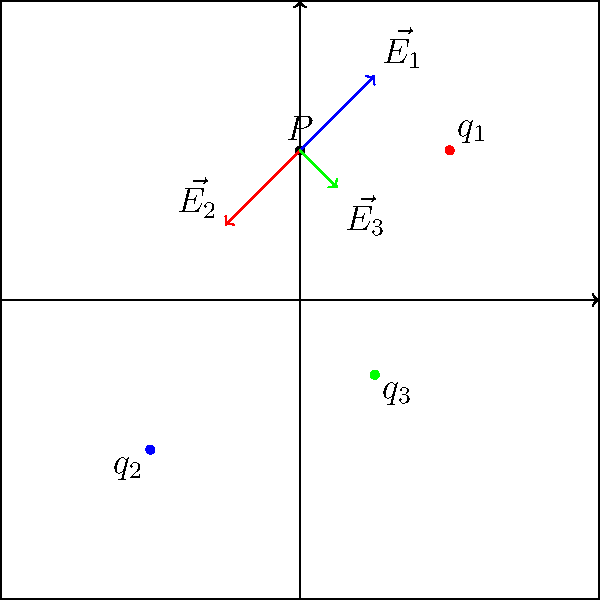In a disordered system, three charged particles are located at positions $\vec{r_1} = (1,1)$, $\vec{r_2} = (-1,-1)$, and $\vec{r_3} = (0.5,-0.5)$ with charges $q_1 = 2e$, $q_2 = -e$, and $q_3 = e$ respectively, where $e$ is the elementary charge. Calculate the total electric field vector $\vec{E_{total}}$ at point $P(0,1)$. Assume the system is in vacuum with permittivity $\epsilon_0$. Express your answer in terms of $\frac{e}{4\pi\epsilon_0}$ and give the x and y components separately. To solve this problem, we'll follow these steps:

1) First, we need to calculate the electric field vector due to each charge using the formula:

   $$\vec{E_i} = \frac{1}{4\pi\epsilon_0} \frac{q_i}{r_i^2} \hat{r_i}$$

   where $\hat{r_i}$ is the unit vector pointing from the charge to point P.

2) For charge $q_1$:
   $\vec{r_{1P}} = (0,1) - (1,1) = (-1,0)$
   $r_1 = \sqrt{(-1)^2 + 0^2} = 1$
   $\hat{r_1} = (-1,0)$
   $$\vec{E_1} = \frac{1}{4\pi\epsilon_0} \frac{2e}{1^2} (-1,0) = -\frac{e}{2\pi\epsilon_0} (1,0)$$

3) For charge $q_2$:
   $\vec{r_{2P}} = (0,1) - (-1,-1) = (1,2)$
   $r_2 = \sqrt{1^2 + 2^2} = \sqrt{5}$
   $\hat{r_2} = (\frac{1}{\sqrt{5}},\frac{2}{\sqrt{5}})$
   $$\vec{E_2} = \frac{1}{4\pi\epsilon_0} \frac{-e}{5} (\frac{1}{\sqrt{5}},\frac{2}{\sqrt{5}}) = -\frac{e}{20\pi\epsilon_0} (\frac{1}{\sqrt{5}},\frac{2}{\sqrt{5}})$$

4) For charge $q_3$:
   $\vec{r_{3P}} = (0,1) - (0.5,-0.5) = (-0.5,1.5)$
   $r_3 = \sqrt{(-0.5)^2 + (1.5)^2} = \sqrt{2.5}$
   $\hat{r_3} = (-\frac{1}{\sqrt{10}},\frac{3}{\sqrt{10}})$
   $$\vec{E_3} = \frac{1}{4\pi\epsilon_0} \frac{e}{2.5} (-\frac{1}{\sqrt{10}},\frac{3}{\sqrt{10}}) = \frac{e}{10\pi\epsilon_0} (-\frac{1}{\sqrt{10}},\frac{3}{\sqrt{10}})$$

5) The total electric field is the vector sum of these individual fields:

   $$\vec{E_{total}} = \vec{E_1} + \vec{E_2} + \vec{E_3}$$

6) Adding the x and y components separately:

   $$E_x = -\frac{e}{2\pi\epsilon_0} - \frac{e}{20\pi\epsilon_0\sqrt{5}} - \frac{e}{10\pi\epsilon_0\sqrt{10}}$$
   $$E_y = -\frac{e\sqrt{5}}{50\pi\epsilon_0} + \frac{3e}{10\pi\epsilon_0\sqrt{10}}$$

7) Simplifying and expressing in terms of $\frac{e}{4\pi\epsilon_0}$:

   $$E_x = -\frac{e}{4\pi\epsilon_0}(2 + \frac{1}{5\sqrt{5}} + \frac{2}{5\sqrt{10}})$$
   $$E_y = \frac{e}{4\pi\epsilon_0}(-\frac{2\sqrt{5}}{25} + \frac{6}{5\sqrt{10}})$$
Answer: $\vec{E_{total}} = -\frac{e}{4\pi\epsilon_0}(2 + \frac{1}{5\sqrt{5}} + \frac{2}{5\sqrt{10}}, -\frac{2\sqrt{5}}{25} + \frac{6}{5\sqrt{10}})$ 